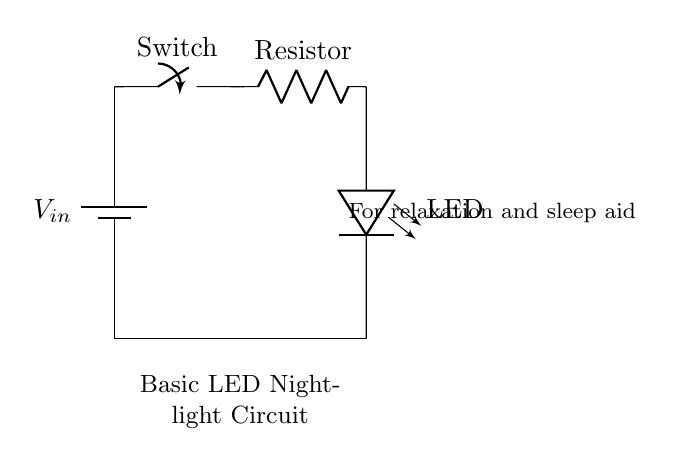What is the input voltage of this circuit? The input voltage is represented as V_in in the battery symbol. It is typically a direct current voltage that powers the circuit.
Answer: V_in What component is used as a light source? The component used for illumination in this circuit is indicated as LED, which stands for Light Emitting Diode. LEDs are commonly used for low-power lighting applications.
Answer: LED How many resistors are present in this circuit? The circuit contains one resistor, which is connected in series with the LED to limit the current flowing through it, protecting the LED from excessive current.
Answer: 1 What is the role of the switch in the circuit? The switch allows the user to control the flow of electricity in the circuit. When closed, it completes the circuit, allowing current to flow to the rest of the components; when open, it interrupts the circuit.
Answer: Control flow If the LED is glowing, what can you infer about the switch? If the LED is glowing, this indicates that the switch is closed since a closed switch allows current to travel through the circuit and power the LED.
Answer: Closed What type of circuit is this? This is a simple series circuit since all components are connected in a single path for current flow, meaning that the current passing through each component is the same.
Answer: Series circuit What might be a primary purpose of building this circuit? The primary purpose of this circuit is to provide a gentle light source for relaxation and sleep aid, often used to create a calming atmosphere in a bedroom.
Answer: Relaxation 